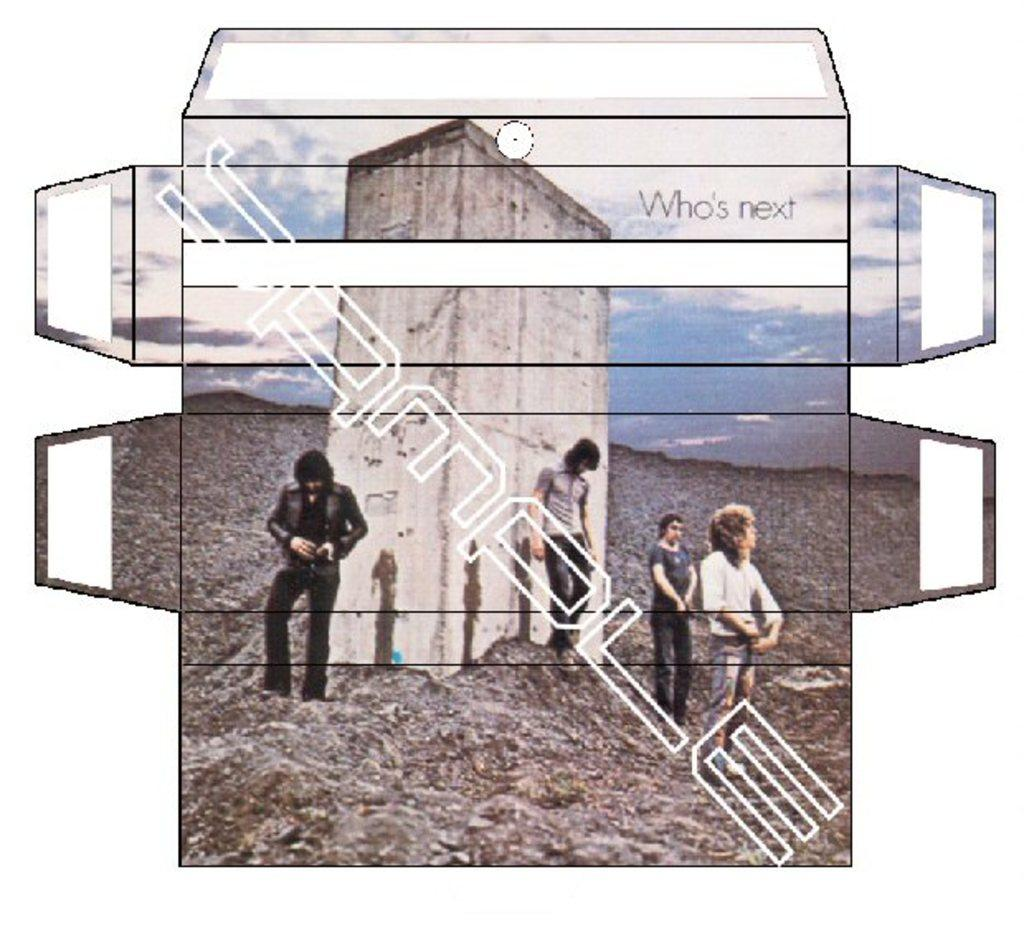How many persons are in the image? There are persons standing in the image. What is the surface on which the persons are standing? The persons are standing on the ground. What structure can be seen in the image? There is a building in the image. What is visible in the background of the image? The sky is visible in the image, and clouds are present in the sky. What type of neck accessory is worn by the persons in the image? There is no information about any neck accessory worn by the persons in the image. 